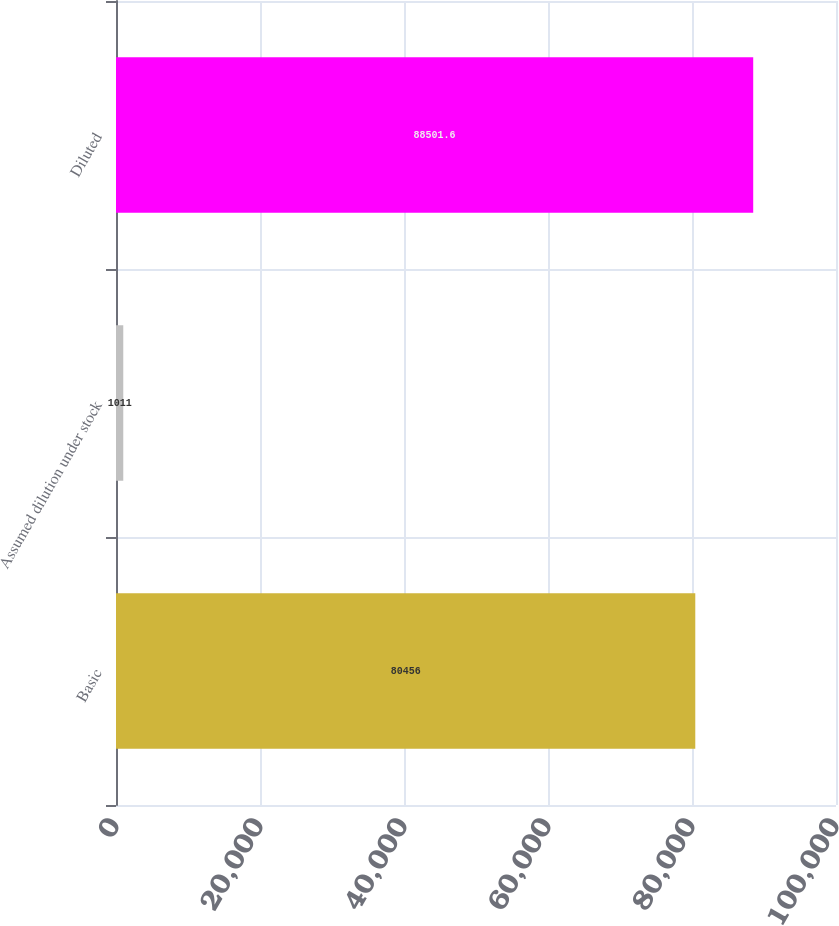<chart> <loc_0><loc_0><loc_500><loc_500><bar_chart><fcel>Basic<fcel>Assumed dilution under stock<fcel>Diluted<nl><fcel>80456<fcel>1011<fcel>88501.6<nl></chart> 